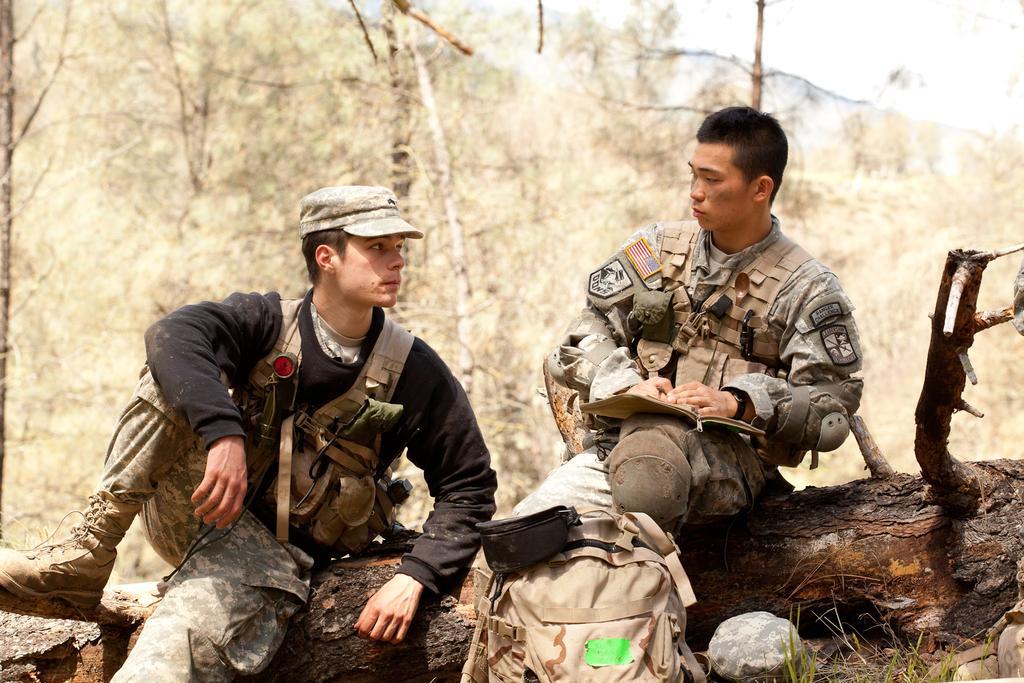Can you describe this image briefly? In this image I can see two persons are sitting on a tree trunk, bag and some objects. In the background I can see grass, stones, trees and the sky. This image is taken may be in the forest. 